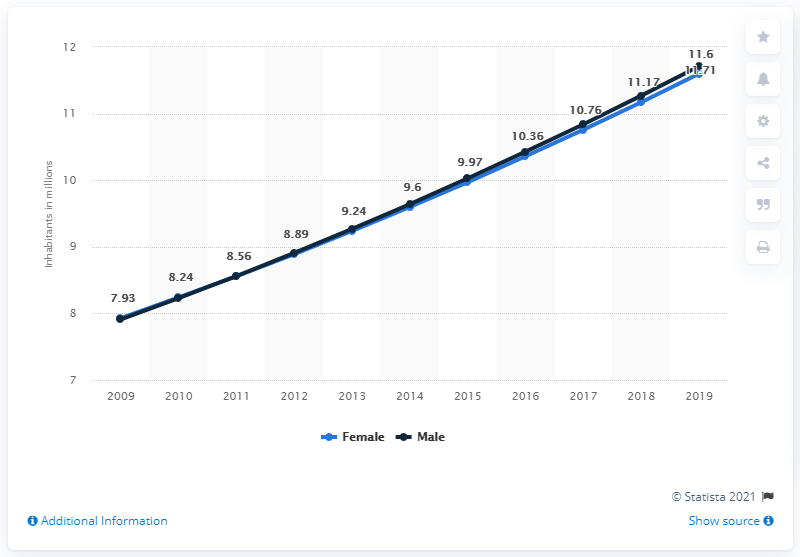Indicate a few pertinent items in this graphic. In 2019, the male population of Niger was 11.6 million. In 2019, the female population of Niger was 11.6 million. 